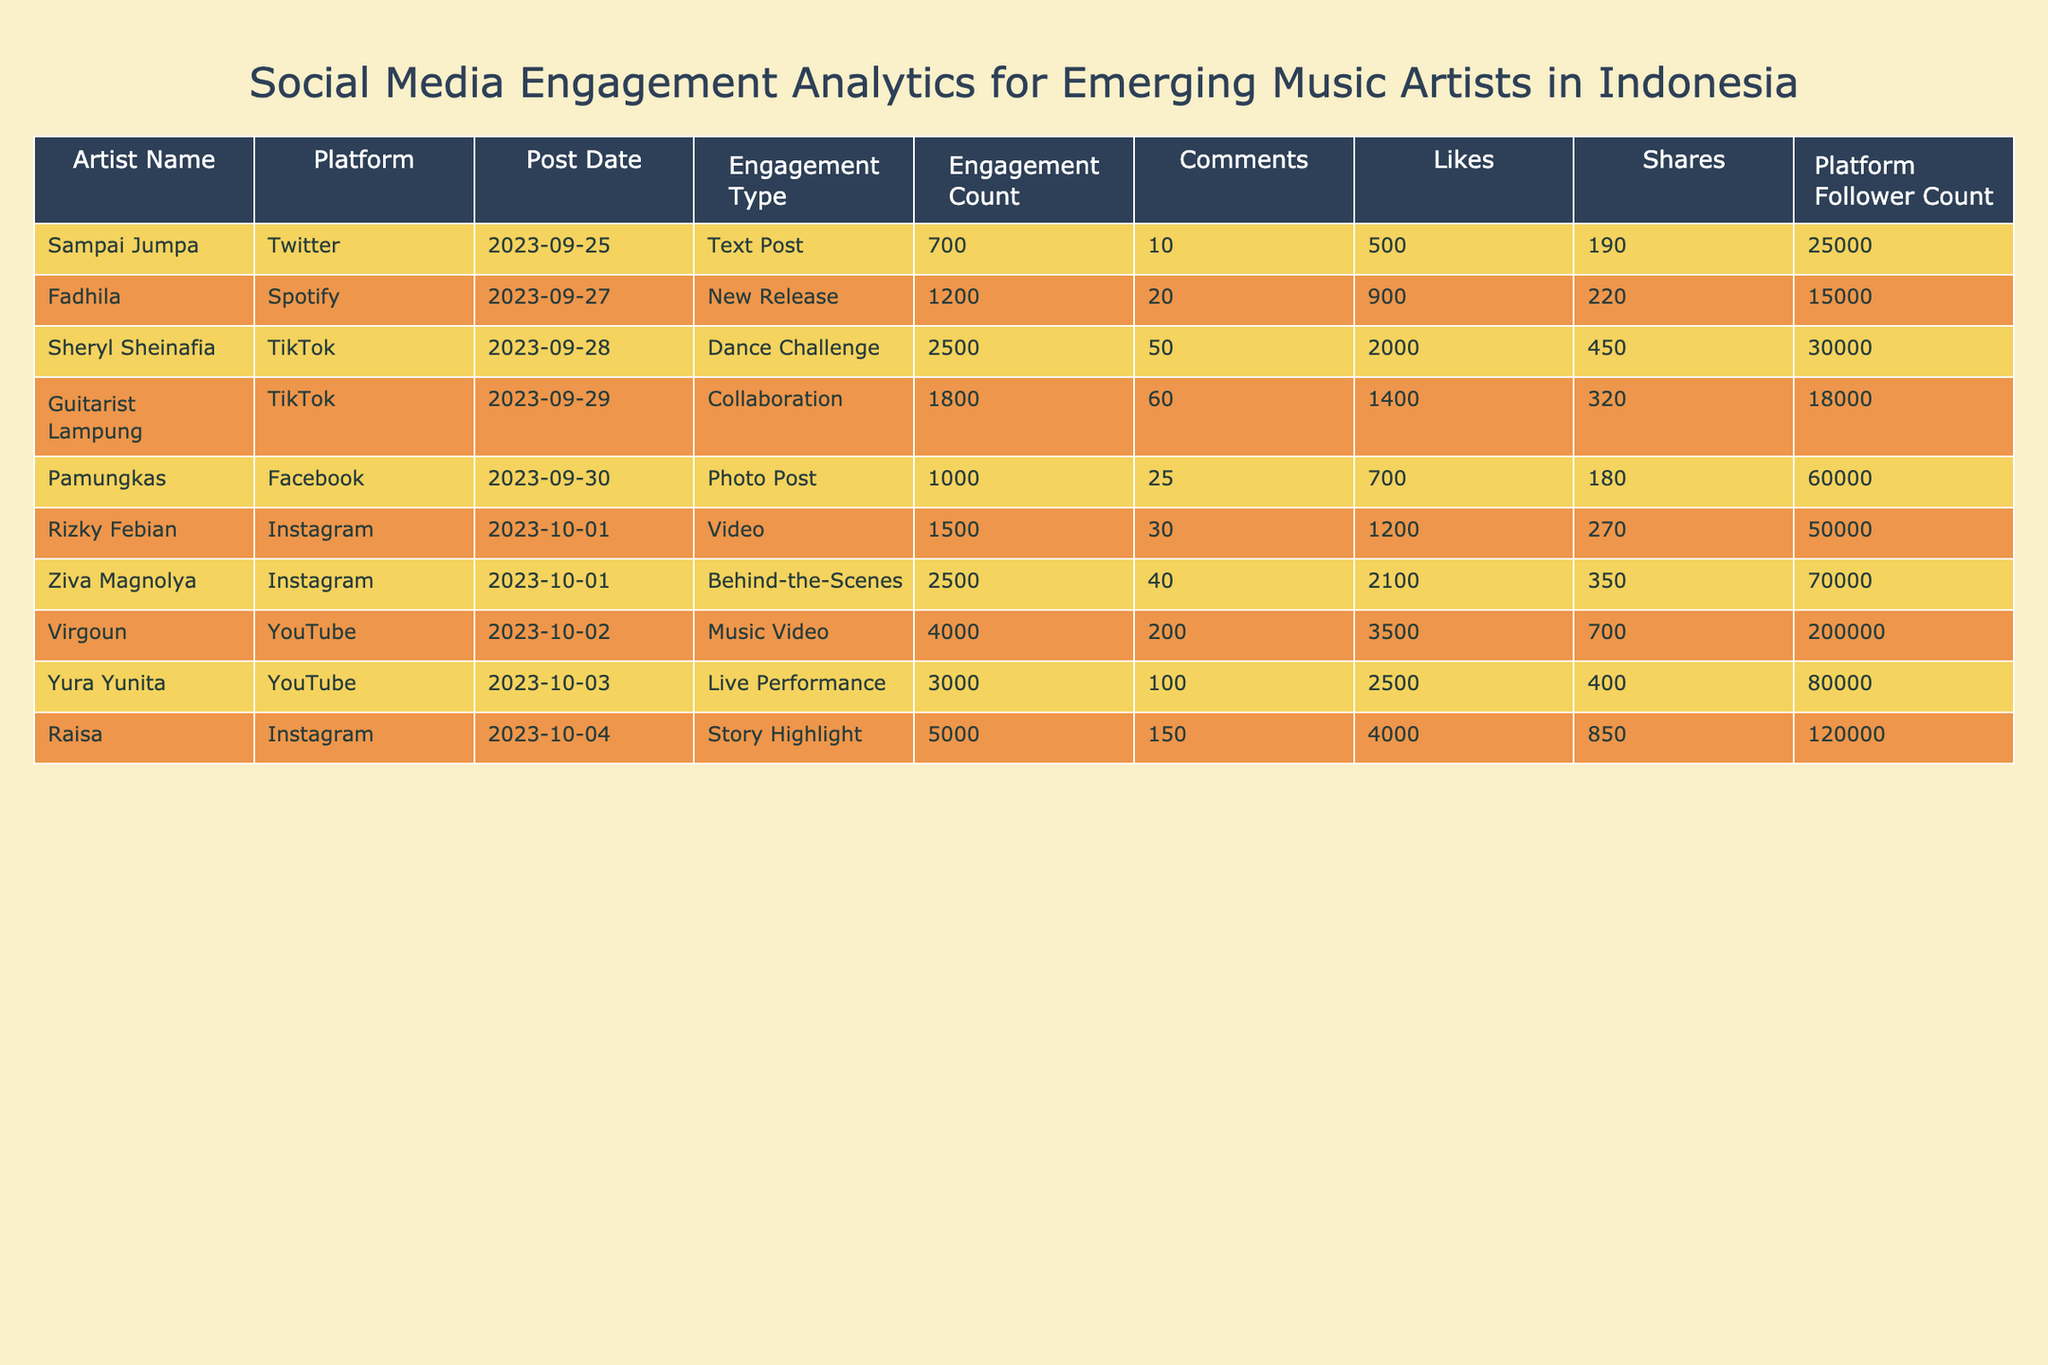What is the platform with the highest engagement count? By reviewing the "Engagement Count" column, we see that Raisa on Instagram has the highest value, which is 5000.
Answer: Instagram Which artist had the most shares on their post? Looking at the "Shares" column, we see that Raisa has 850 shares, which is more than any other artist listed.
Answer: Raisa What is the average engagement count across all artists? To find the average, we sum the engagement counts: (1500 + 2500 + 3000 + 700 + 1000 + 5000 + 1200 + 4000 + 1800 + 2500) = 18500. Then divide by the number of artists (10), so 18500 / 10 = 1850.
Answer: 1850 Did any artist have a follower count over 100,000 on their platform? By checking the "Platform Follower Count" column, we find that Raisa has 120,000 followers, which is above 100,000. Therefore, the answer is yes.
Answer: Yes Which artist had the lowest engagement count and what was it? Looking through the "Engagement Count" column, we see that Sampai Jumpa has the lowest count at 700.
Answer: 700 What is the total number of likes generated by all posts? To find the total likes, we sum the likes column: (1200 + 2000 + 2500 + 500 + 700 + 4000 + 900 + 3500 + 1400 + 2100) = 18800.
Answer: 18800 How many comments did Yura Yunita receive on her live performance post? Referring to the "Comments" column, Yura Yunita received 100 comments on her live performance post.
Answer: 100 Is there any post that is a dance challenge and what was its engagement count? Checking the "Engagement Type" column, Sheryl Sheinafia's post qualifies as a dance challenge, with an engagement count of 2500.
Answer: 2500 Which platform had the most diverse types of engagement types shown in the table? Analyzing the "Platform" and "Engagement Type" columns, all platforms show different engagement types but Instagram and YouTube have multiple entries, thus indicating more diversity.
Answer: Instagram and YouTube 